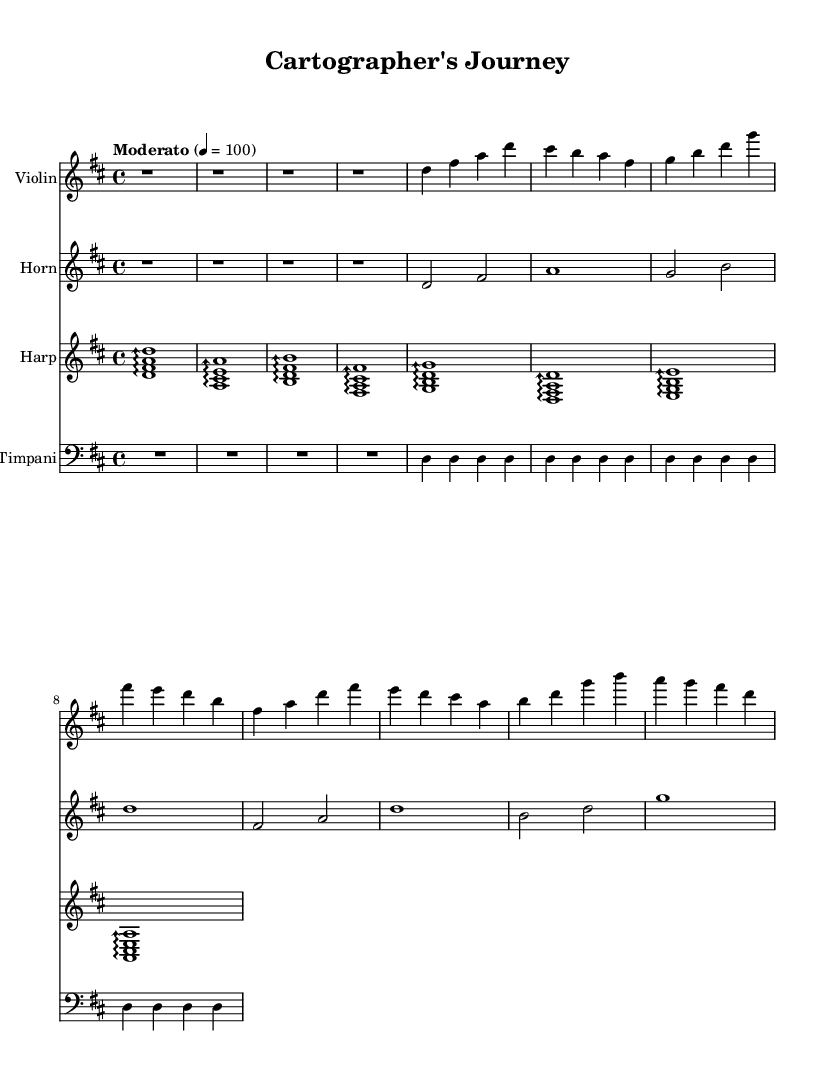What is the key signature of this music? The key signature is D major, which has two sharps (F# and C#). This can be identified by looking at the key signature symbols at the beginning of the staff lines.
Answer: D major What is the time signature of this piece? The time signature is four-four, which indicates there are four beats in each measure. This is shown at the beginning of the score with the 4/4 notation.
Answer: 4/4 What is the tempo marking for this piece? The tempo marking is "Moderato" with a metronome marking of 100, meaning it should be played at a moderate speed of 100 beats per minute. This is found in the tempo instruction following the time signature.
Answer: Moderato How many measures are used in the introduction section? The introduction section consists of four measures, which are identified by the rests represented in the sheet music. Each rest symbol represents one measure, and there are four of them before any notes appear.
Answer: 4 What instruments are featured in this score? The featured instruments are violin, horn, harp, and timpani. This can be determined by looking at the staff labels at the beginning of each instrument’s section in the score.
Answer: Violin, horn, harp, timpani Which theme appears first in the score? The first theme in the score is Theme A, which starts right after the introduction. This can be identified in the score by the sequence of notes that follows the rests of the introduction.
Answer: Theme A What is the total number of different musical themes present in this score? There are two different musical themes present in the score: Theme A and Theme B. This can be deduced by analyzing the sections labeled in the score, as each theme has a distinct sequence of notes that follows it.
Answer: 2 